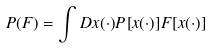Convert formula to latex. <formula><loc_0><loc_0><loc_500><loc_500>P ( F ) = \int D x ( \cdot ) P [ x ( \cdot ) ] F [ x ( \cdot ) ]</formula> 